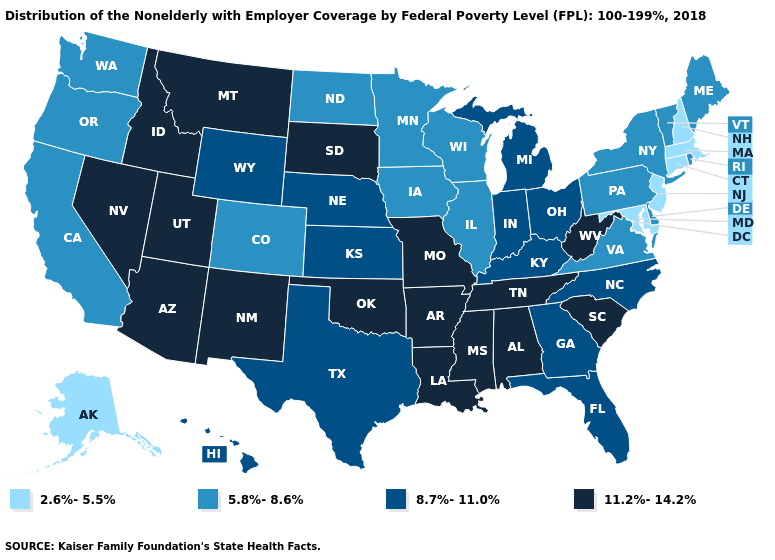Does Pennsylvania have a higher value than Florida?
Short answer required. No. What is the value of Colorado?
Give a very brief answer. 5.8%-8.6%. Name the states that have a value in the range 8.7%-11.0%?
Be succinct. Florida, Georgia, Hawaii, Indiana, Kansas, Kentucky, Michigan, Nebraska, North Carolina, Ohio, Texas, Wyoming. What is the value of Missouri?
Concise answer only. 11.2%-14.2%. Which states have the lowest value in the Northeast?
Short answer required. Connecticut, Massachusetts, New Hampshire, New Jersey. Does New York have a lower value than Maryland?
Be succinct. No. Does Ohio have the same value as California?
Keep it brief. No. Among the states that border Minnesota , does Iowa have the highest value?
Be succinct. No. What is the highest value in states that border Vermont?
Give a very brief answer. 5.8%-8.6%. Name the states that have a value in the range 2.6%-5.5%?
Write a very short answer. Alaska, Connecticut, Maryland, Massachusetts, New Hampshire, New Jersey. Name the states that have a value in the range 5.8%-8.6%?
Answer briefly. California, Colorado, Delaware, Illinois, Iowa, Maine, Minnesota, New York, North Dakota, Oregon, Pennsylvania, Rhode Island, Vermont, Virginia, Washington, Wisconsin. Name the states that have a value in the range 8.7%-11.0%?
Short answer required. Florida, Georgia, Hawaii, Indiana, Kansas, Kentucky, Michigan, Nebraska, North Carolina, Ohio, Texas, Wyoming. Among the states that border Nevada , does California have the highest value?
Give a very brief answer. No. What is the lowest value in the USA?
Answer briefly. 2.6%-5.5%. Name the states that have a value in the range 11.2%-14.2%?
Give a very brief answer. Alabama, Arizona, Arkansas, Idaho, Louisiana, Mississippi, Missouri, Montana, Nevada, New Mexico, Oklahoma, South Carolina, South Dakota, Tennessee, Utah, West Virginia. 